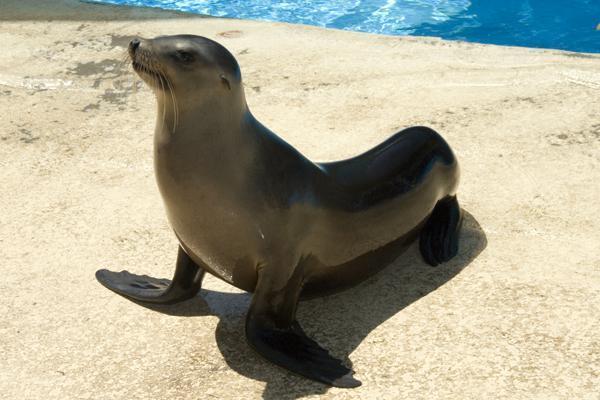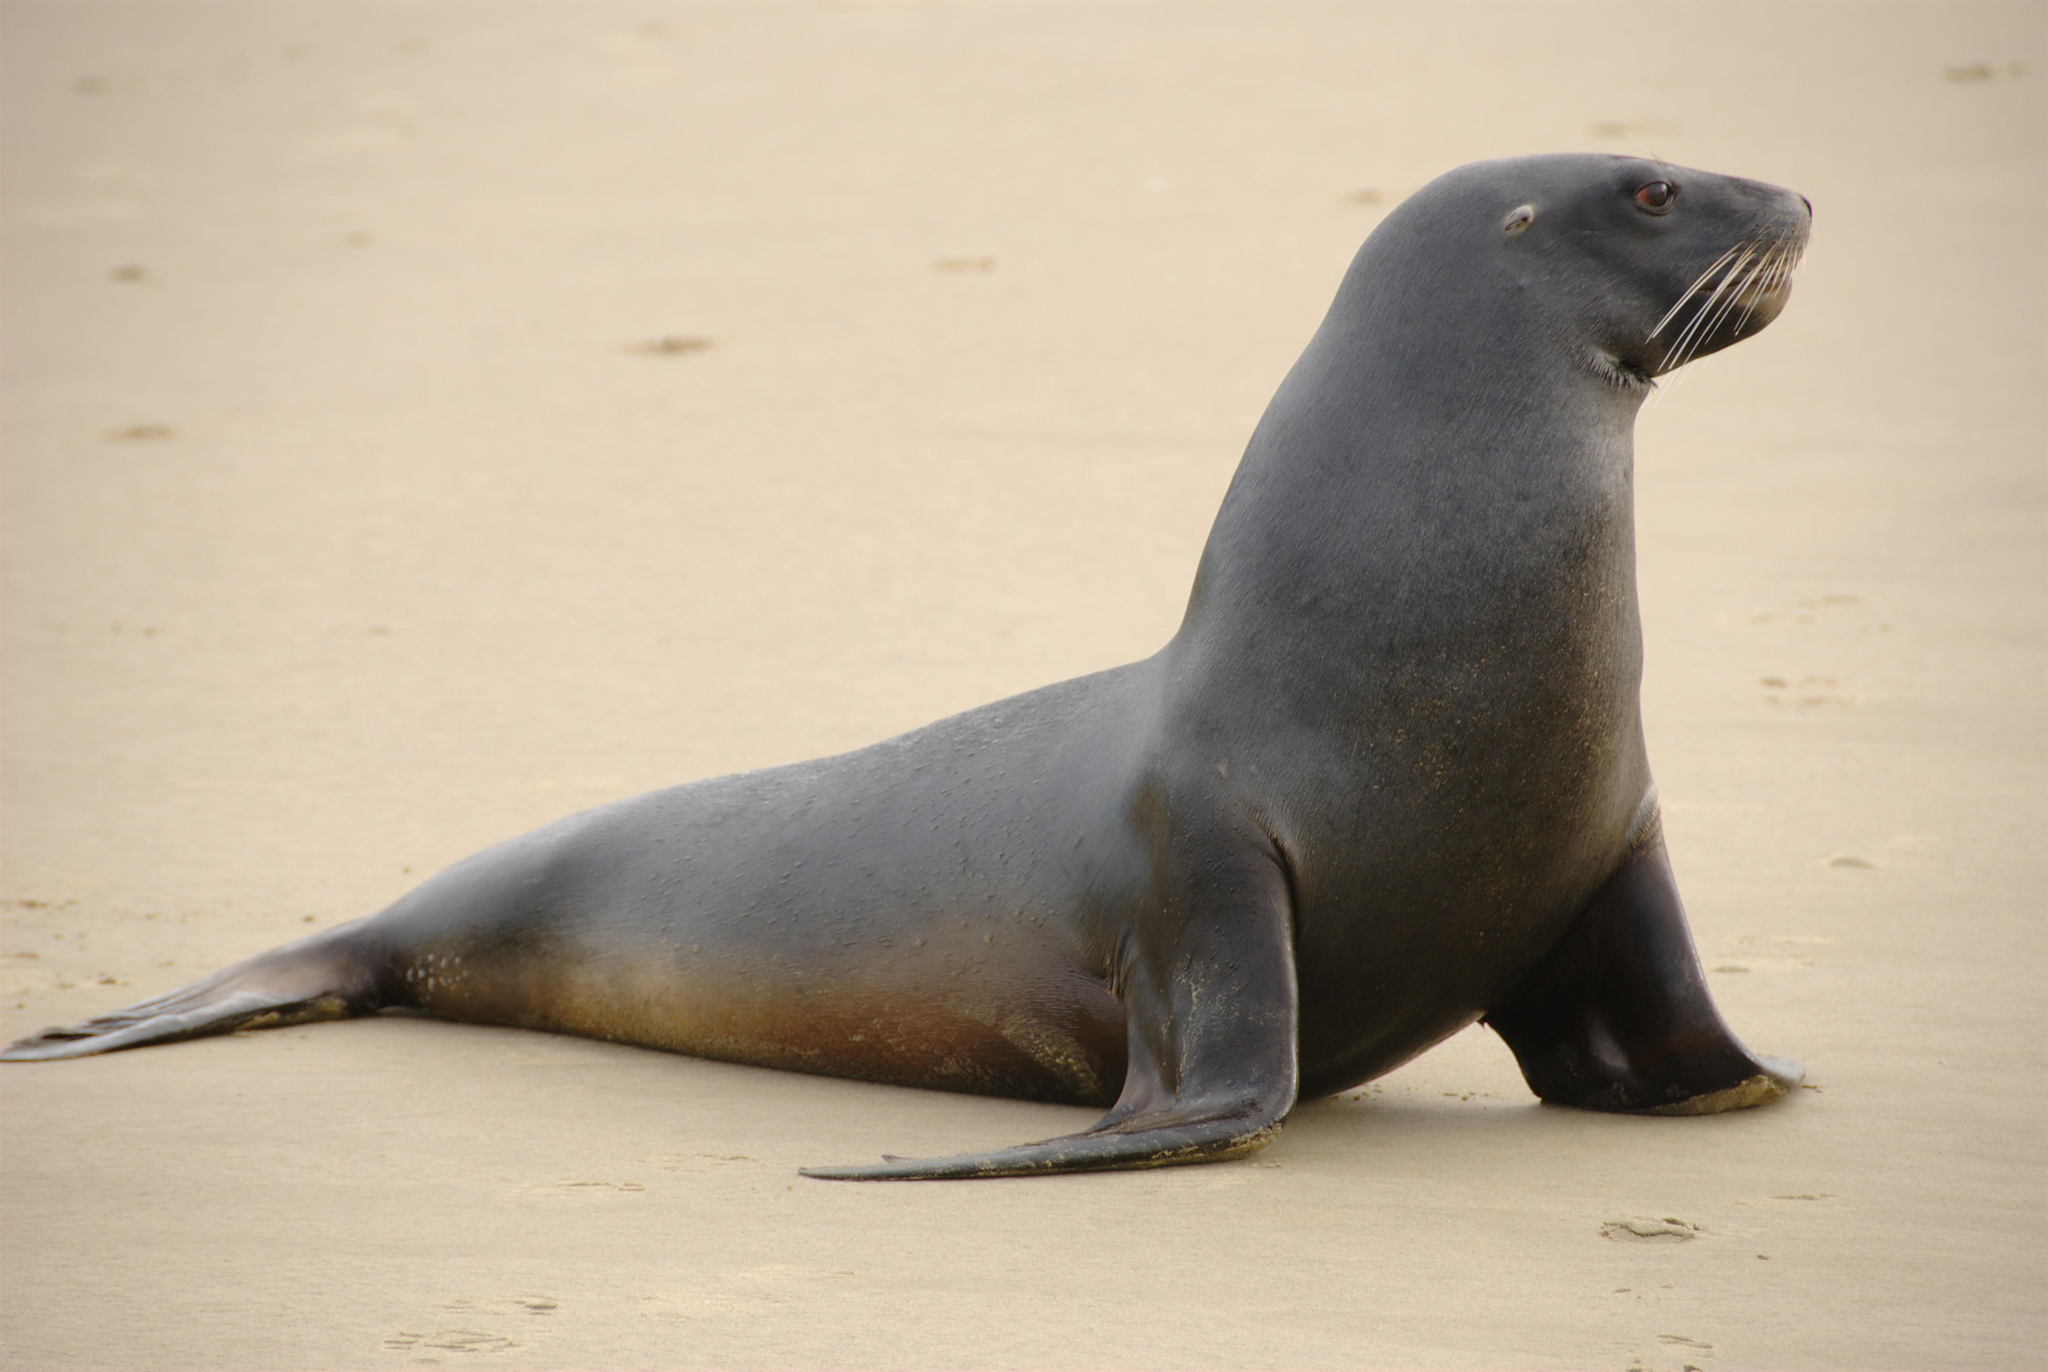The first image is the image on the left, the second image is the image on the right. Considering the images on both sides, is "The seals in the right and left images have their bodies turned in different [left vs right] directions, and no seals shown are babies." valid? Answer yes or no. Yes. The first image is the image on the left, the second image is the image on the right. Considering the images on both sides, is "There is one seal with a plain white background." valid? Answer yes or no. No. 